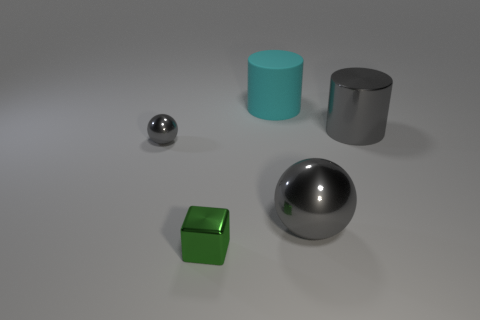Subtract all cyan cylinders. How many cylinders are left? 1 Add 2 small green blocks. How many objects exist? 7 Subtract 1 green cubes. How many objects are left? 4 Subtract all cubes. How many objects are left? 4 Subtract 1 balls. How many balls are left? 1 Subtract all gray cylinders. Subtract all gray blocks. How many cylinders are left? 1 Subtract all red cubes. How many blue balls are left? 0 Subtract all cylinders. Subtract all gray metallic things. How many objects are left? 0 Add 2 metallic things. How many metallic things are left? 6 Add 1 green things. How many green things exist? 2 